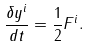Convert formula to latex. <formula><loc_0><loc_0><loc_500><loc_500>\frac { \delta y ^ { i } } { d t } = \frac { 1 } { 2 } F ^ { i } .</formula> 